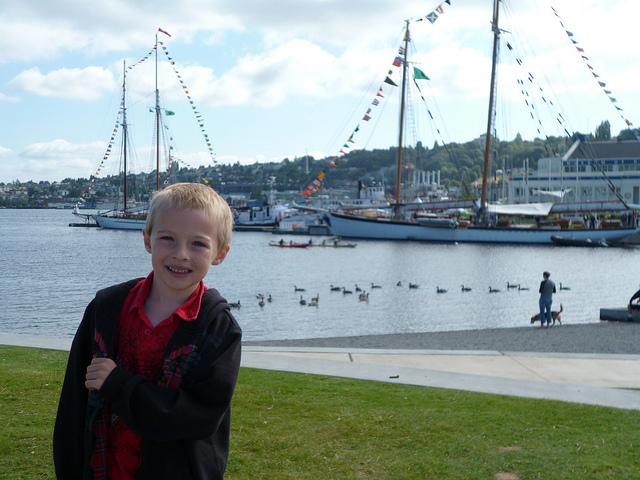Where is a man with a dog?
Write a very short answer. Near water. What creatures are swimming in the water?
Answer briefly. Ducks. Is the person in the foreground a girl?
Concise answer only. No. 